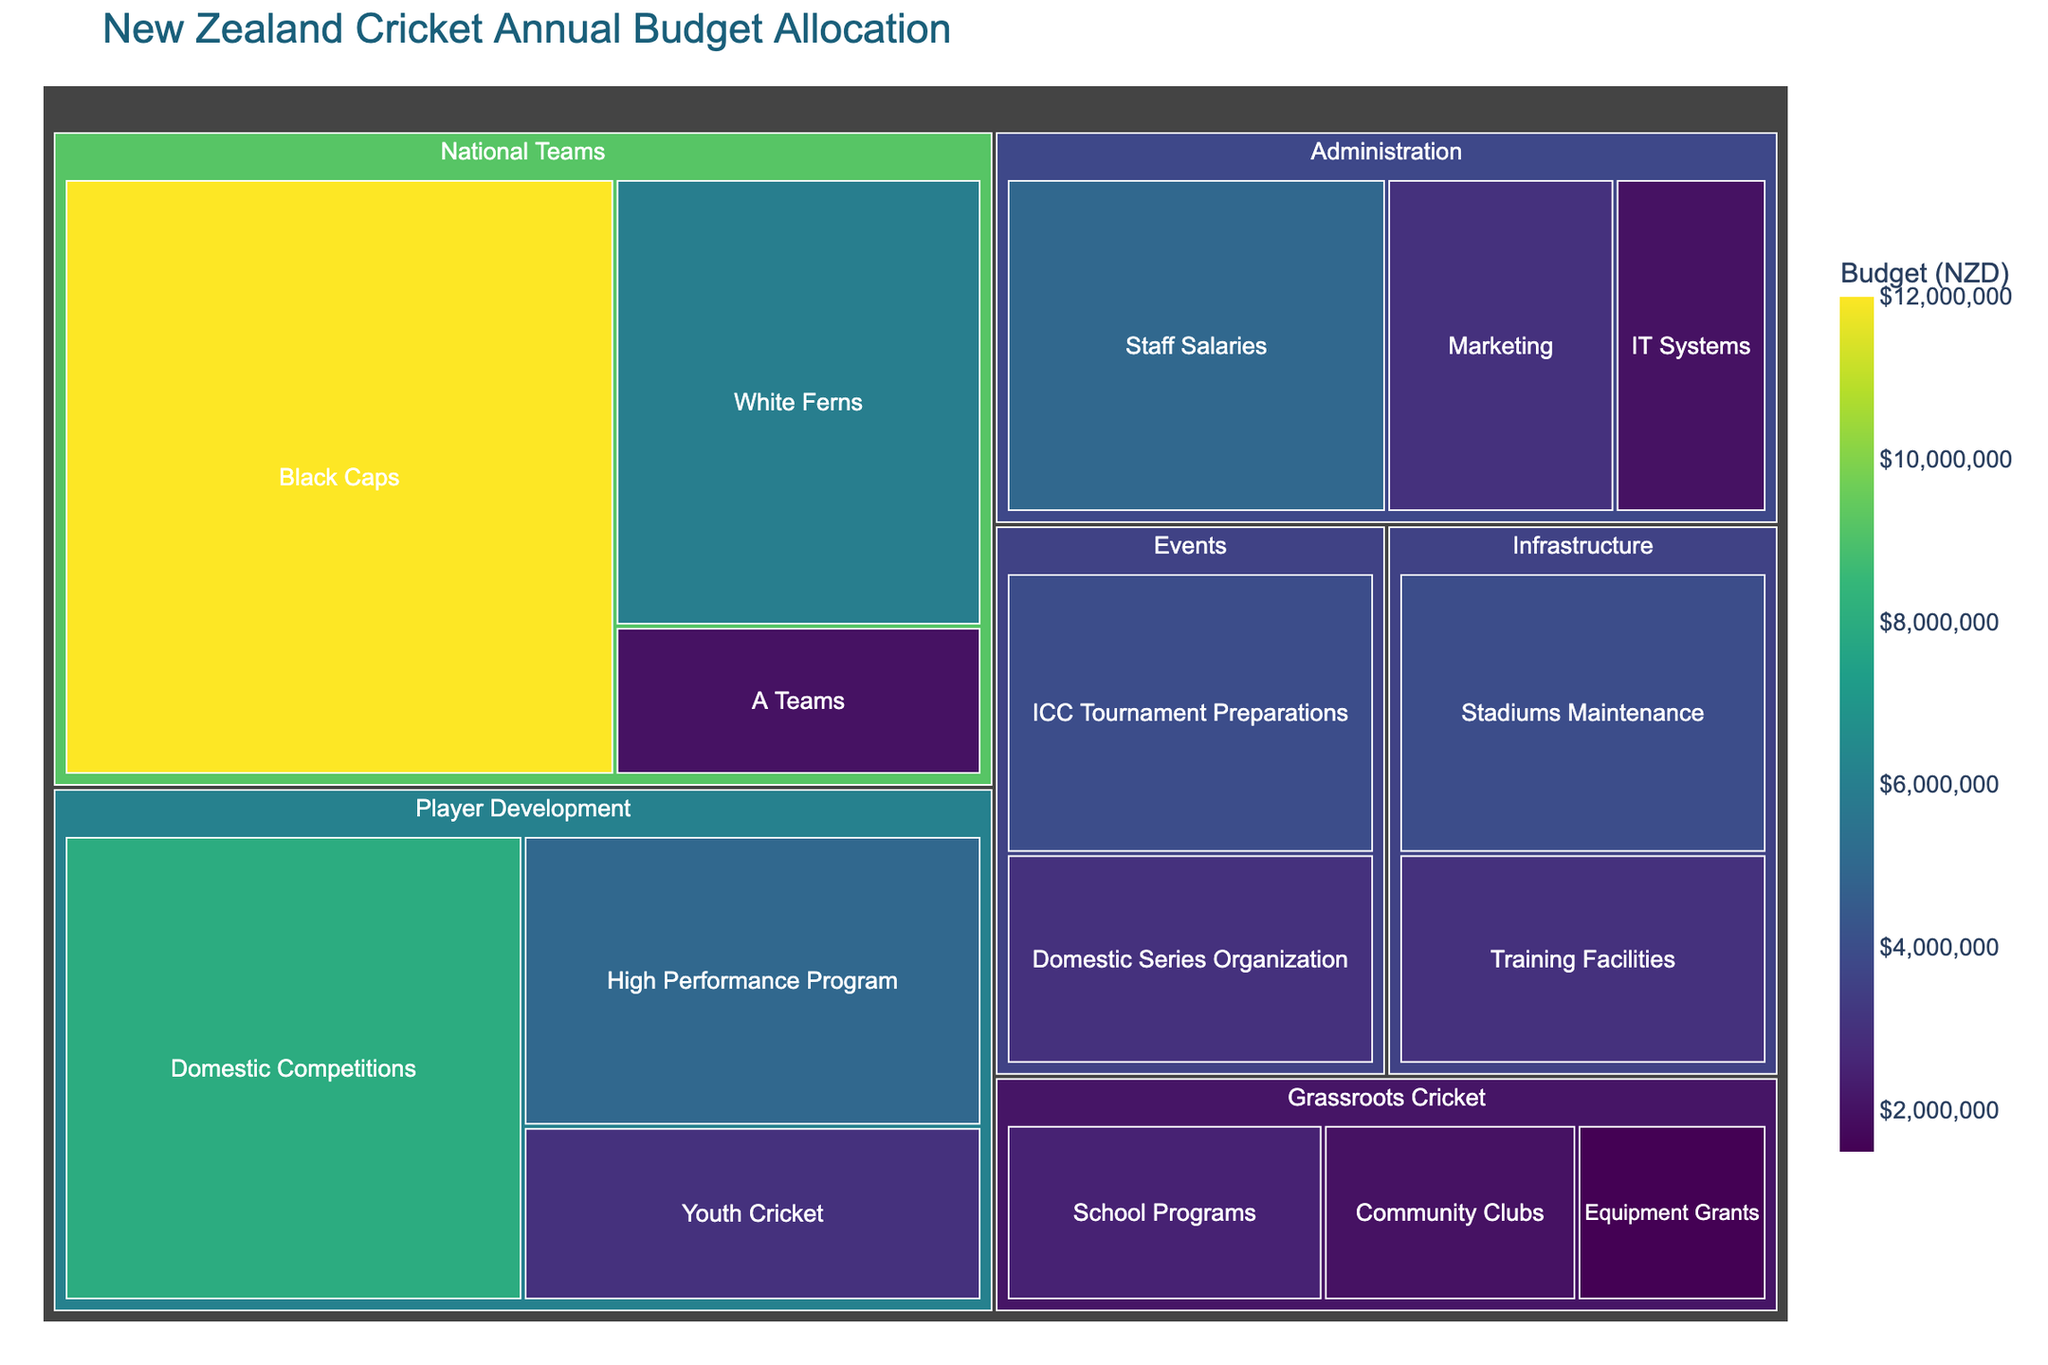What is the title of the treemap? The title is typically found at the top of the treemap and usually summarizes what the visual representation is about.
Answer: New Zealand Cricket Annual Budget Allocation Which subcategory has the highest budget allocation? By looking at the size and value of the tiles, the largest one with the highest value indicates the subcategory with the highest budget. The Black Caps under National Teams has the biggest tile and the highest value of $12,000,000.
Answer: Black Caps What is the total budget allocated to the Player Development category? To find the total budget of Player Development, sum the values of its subcategories: Domestic Competitions ($8,000,000) + High Performance Program ($5,000,000) + Youth Cricket ($3,000,000).
Answer: $16,000,000 How does the budget for Women's National Team (White Ferns) compare to the budget for Men's National Team (Black Caps)? Compare the values of both subcategories, Black Caps has $12,000,000 while White Ferns has $6,000,000.
Answer: The Black Caps have double the budget compared to White Ferns ($12,000,000 vs. $6,000,000) Which subcategory within Grassroots Cricket has the smallest budget? Identify the smallest tile within Grassroots Cricket. Equipment Grants has the smallest tile and a budget of $1,500,000.
Answer: Equipment Grants What is the combined budget for Events category? Sum up the values of the subcategories under Events: ICC Tournament Preparations ($4,000,000) + Domestic Series Organization ($3,000,000).
Answer: $7,000,000 Which category has a larger budget - Infrastructure or Grassroots Cricket? Compare the totals: Infrastructure has ($4,000,000 + $3,000,000) = $7,000,000, while Grassroots Cricket has ($2,500,000 + $2,000,000 + $1,500,000) = $6,000,000.
Answer: Infrastructure How much more is allocated to Domestic Competitions compared to Community Clubs? Subtract the Community Clubs budget from the Domestic Competitions budget: $8,000,000 - $2,000,000.
Answer: $6,000,000 What proportion of the total budget is allocated to National Teams? First, find the total budget by summing all values, then sum the National Teams budget, and divide by the total. Total budget: $54,000,000; National Teams: ($12,000,000 + $6,000,000 + $2,000,000) = $20,000,000; Proportion = $20,000,000 / $54,000,000.
Answer: Approximately 37% In terms of budget allocation, which is prioritized higher, High Performance Program or Training Facilities? Compare the values of the subcategories. High Performance Program ($5,000,000) has a higher value than Training Facilities ($3,000,000).
Answer: High Performance Program 